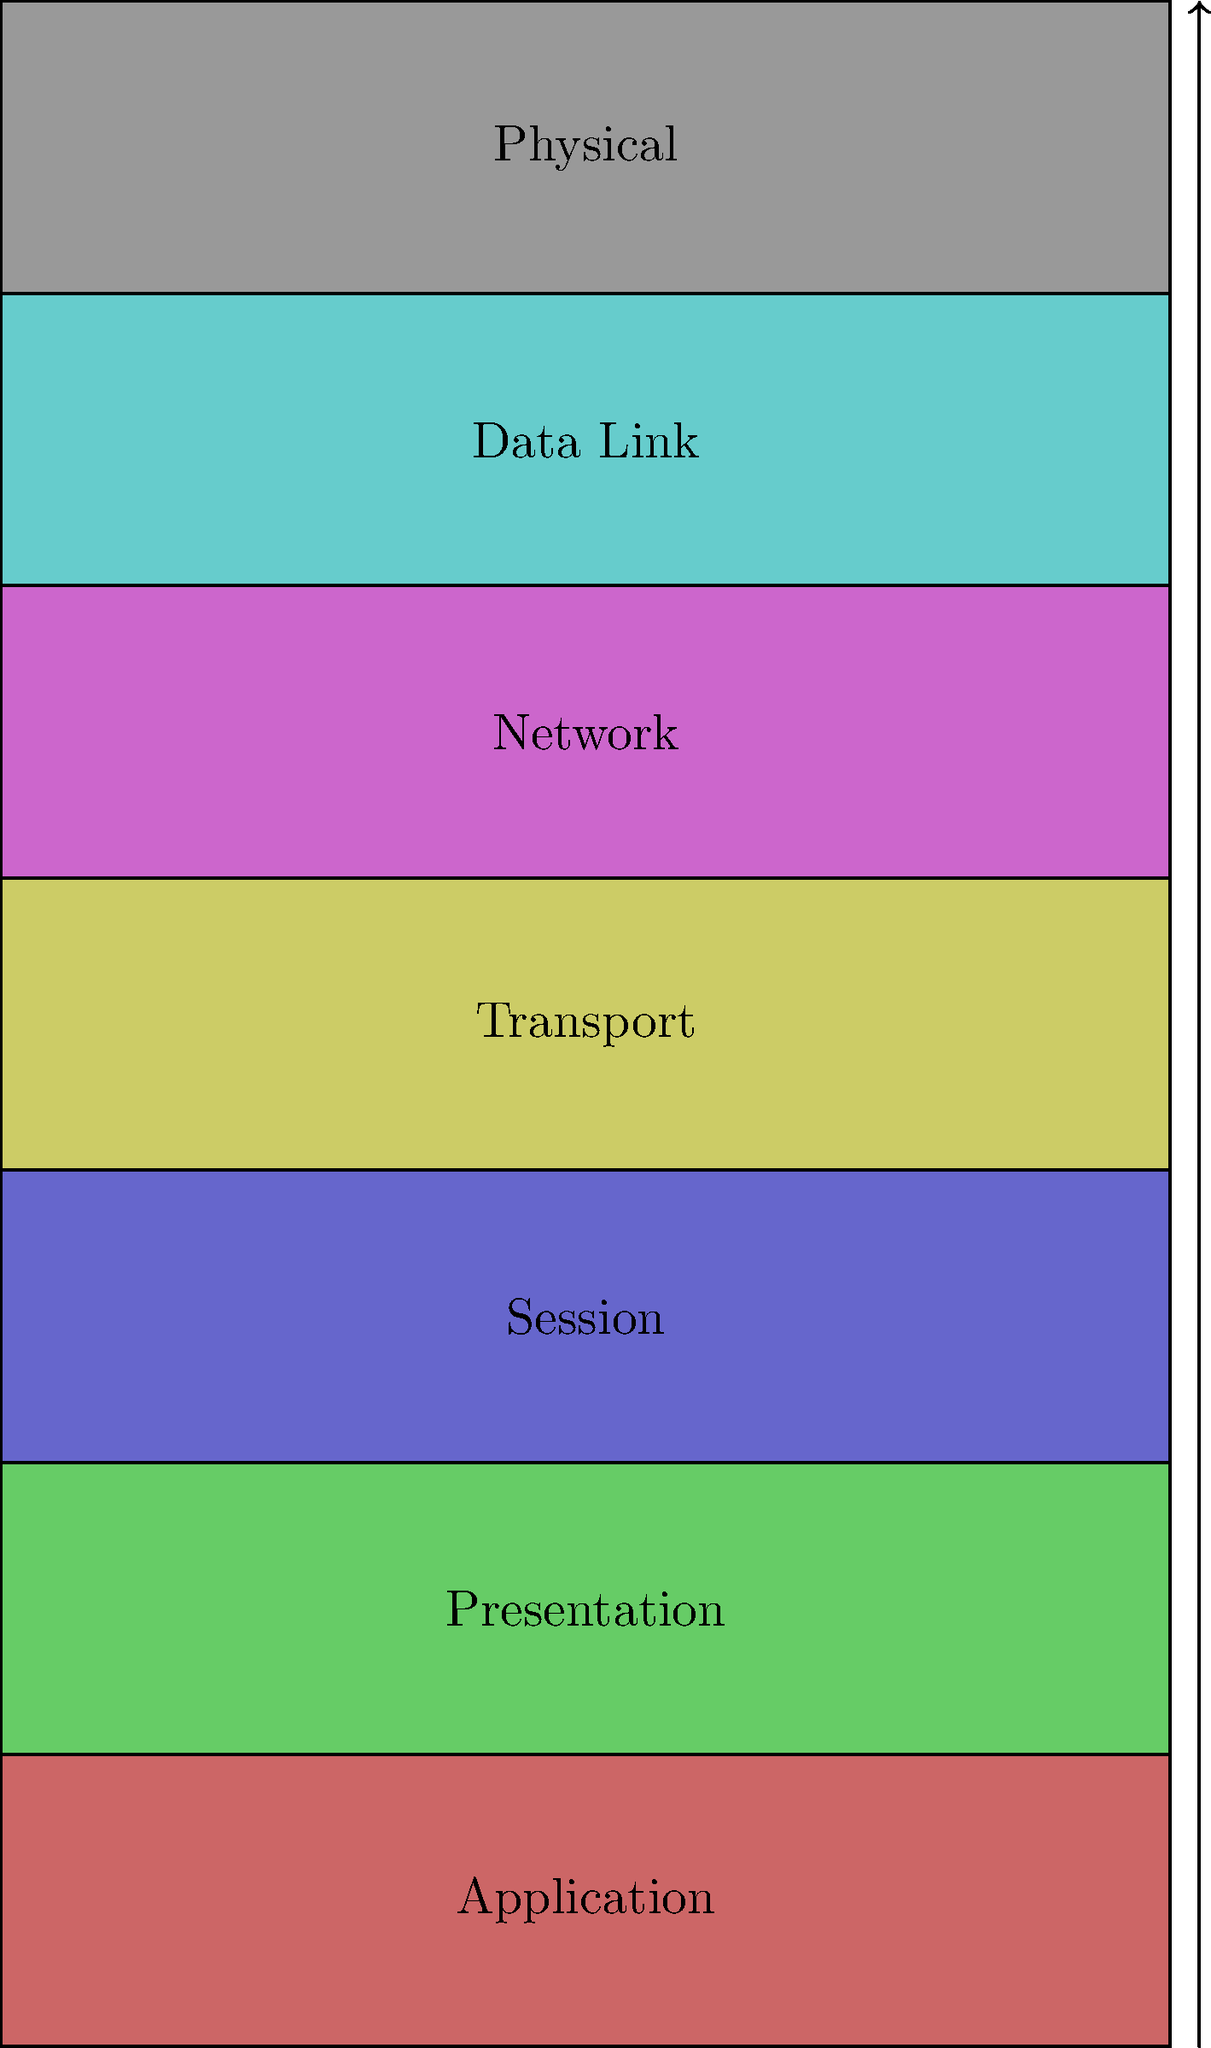In the OSI model diagram shown, which layer is responsible for routing and addressing data packets between different networks? To answer this question, let's examine the OSI (Open Systems Interconnection) model layers from top to bottom:

1. Application Layer: Provides network services directly to end-users or applications.
2. Presentation Layer: Handles data formatting, encryption, and compression.
3. Session Layer: Manages sessions between applications.
4. Transport Layer: Ensures end-to-end communication and data integrity.
5. Network Layer: This layer is responsible for routing and addressing data packets between different networks.
6. Data Link Layer: Handles communication between adjacent network nodes.
7. Physical Layer: Deals with the physical transmission of data over the network medium.

The Network Layer (layer 5 from the bottom or layer 3 from the top) is specifically designed to handle routing and addressing of data packets between different networks. It uses IP addresses to identify the source and destination of packets and determines the best path for data to travel across interconnected networks.

Key functions of the Network Layer include:
1. Logical addressing (e.g., IP addressing)
2. Routing
3. Path determination
4. Packet forwarding

Therefore, the layer responsible for routing and addressing data packets between different networks is the Network Layer.
Answer: Network Layer 